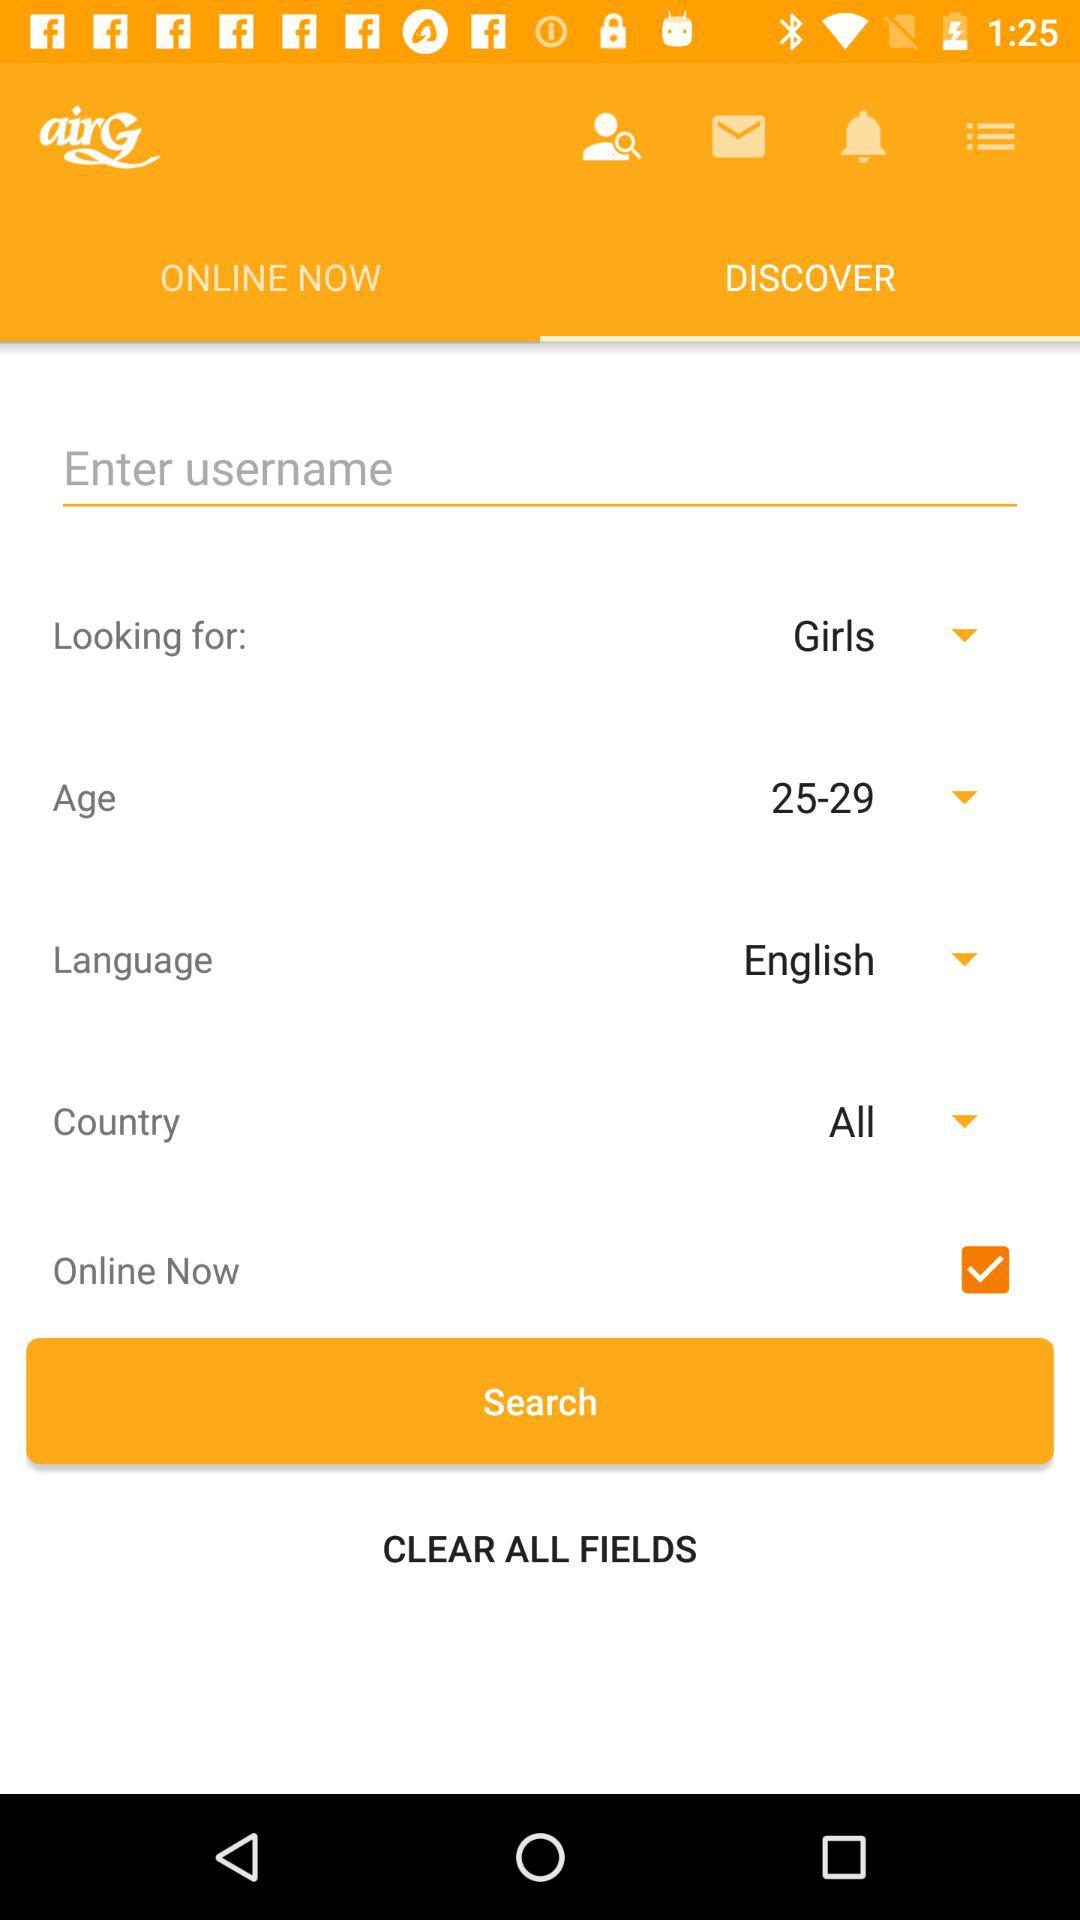What is the selected checkbox? The selected checkbox is "Online Now". 